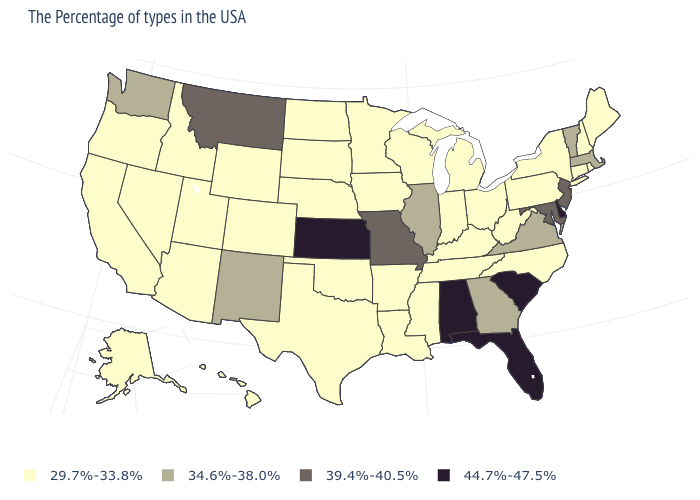Does Ohio have the lowest value in the MidWest?
Keep it brief. Yes. What is the lowest value in the USA?
Quick response, please. 29.7%-33.8%. What is the value of Pennsylvania?
Give a very brief answer. 29.7%-33.8%. What is the value of North Carolina?
Short answer required. 29.7%-33.8%. Which states have the lowest value in the West?
Write a very short answer. Wyoming, Colorado, Utah, Arizona, Idaho, Nevada, California, Oregon, Alaska, Hawaii. Name the states that have a value in the range 34.6%-38.0%?
Be succinct. Massachusetts, Vermont, Virginia, Georgia, Illinois, New Mexico, Washington. What is the value of Tennessee?
Concise answer only. 29.7%-33.8%. Does Hawaii have the same value as Montana?
Quick response, please. No. Does Michigan have the lowest value in the USA?
Write a very short answer. Yes. Which states have the highest value in the USA?
Concise answer only. Delaware, South Carolina, Florida, Alabama, Kansas. Name the states that have a value in the range 39.4%-40.5%?
Keep it brief. New Jersey, Maryland, Missouri, Montana. Name the states that have a value in the range 34.6%-38.0%?
Keep it brief. Massachusetts, Vermont, Virginia, Georgia, Illinois, New Mexico, Washington. What is the value of Delaware?
Concise answer only. 44.7%-47.5%. What is the lowest value in the Northeast?
Concise answer only. 29.7%-33.8%. 